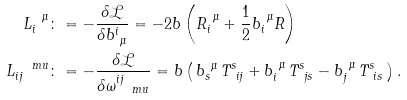<formula> <loc_0><loc_0><loc_500><loc_500>L _ { i } ^ { \ \mu } & \colon = - \frac { \delta \mathcal { L } } { \delta b ^ { i } _ { \ \mu } } = - 2 b \left ( R _ { i } ^ { \ \mu } + \frac { 1 } { 2 } b _ { i } ^ { \ \mu } R \right ) \\ L _ { i j } ^ { \quad m u } & \colon = - \frac { \delta \mathcal { L } } { \delta \omega ^ { i j } _ { \quad m u } } = b \left ( \, b _ { s } ^ { \ \mu } \, T ^ { s } _ { \ i j } + b _ { i } ^ { \ \mu } \, T ^ { s } _ { \ j s } - b _ { j } ^ { \ \mu } \, T ^ { s } _ { \ i s } \, \right ) .</formula> 